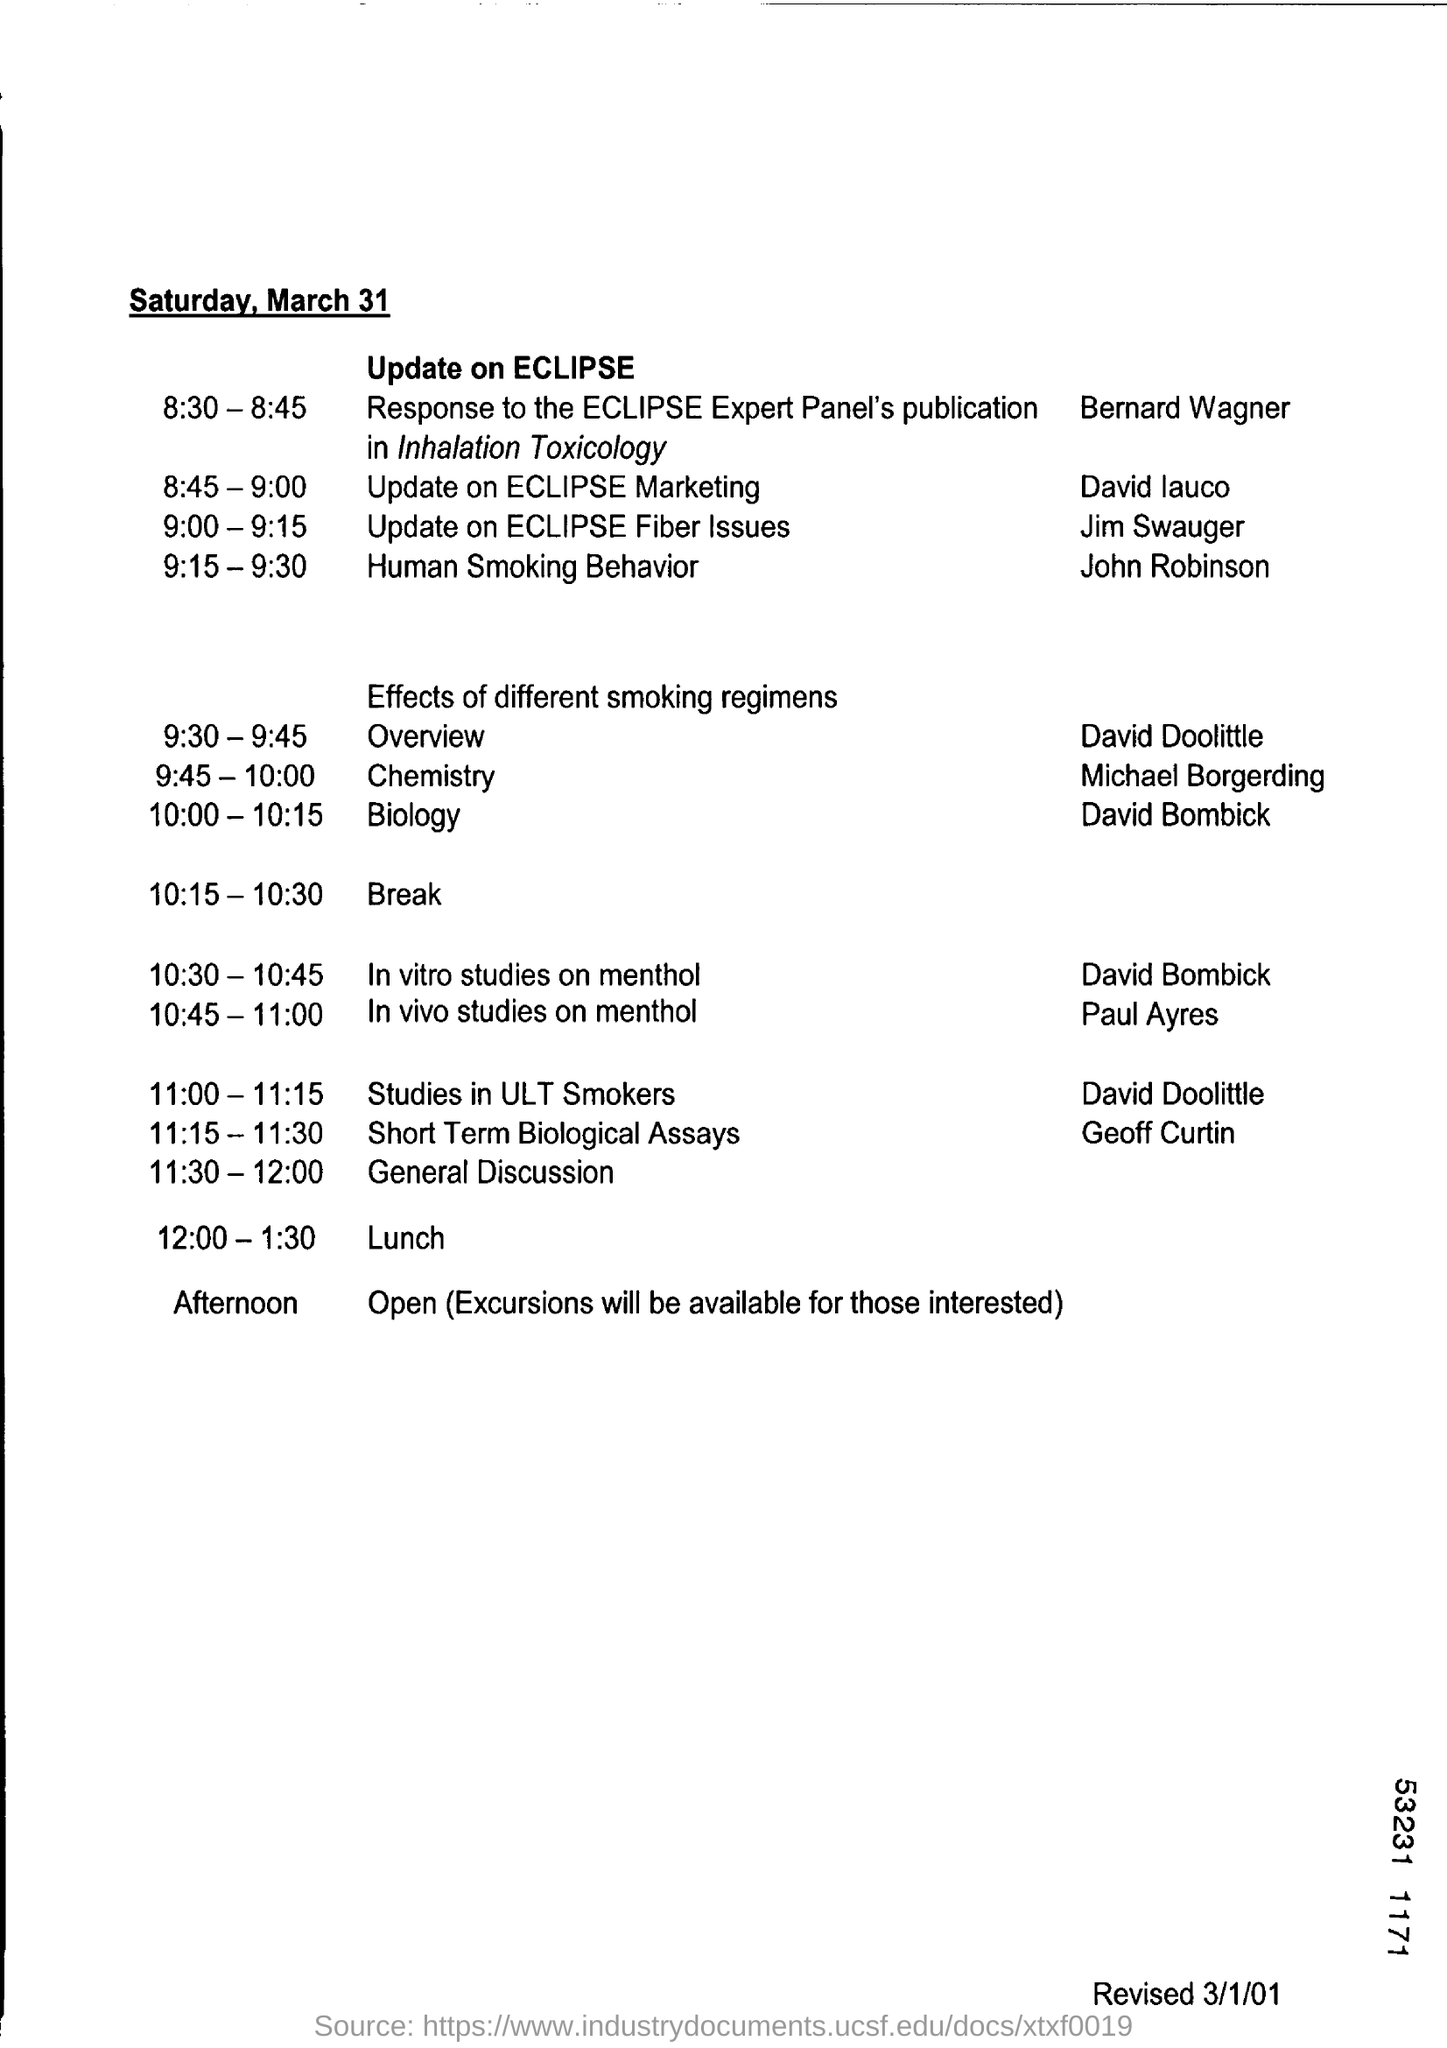What is the event from 9:00- 9.15?
Give a very brief answer. Update on eclipse fiber issues. Who is part of In vitro studies on menthol?
Your response must be concise. David bombick. Which event is headed by Paul Ayres from 10:45-11:00?
Your response must be concise. In vivo studies on menthol. 